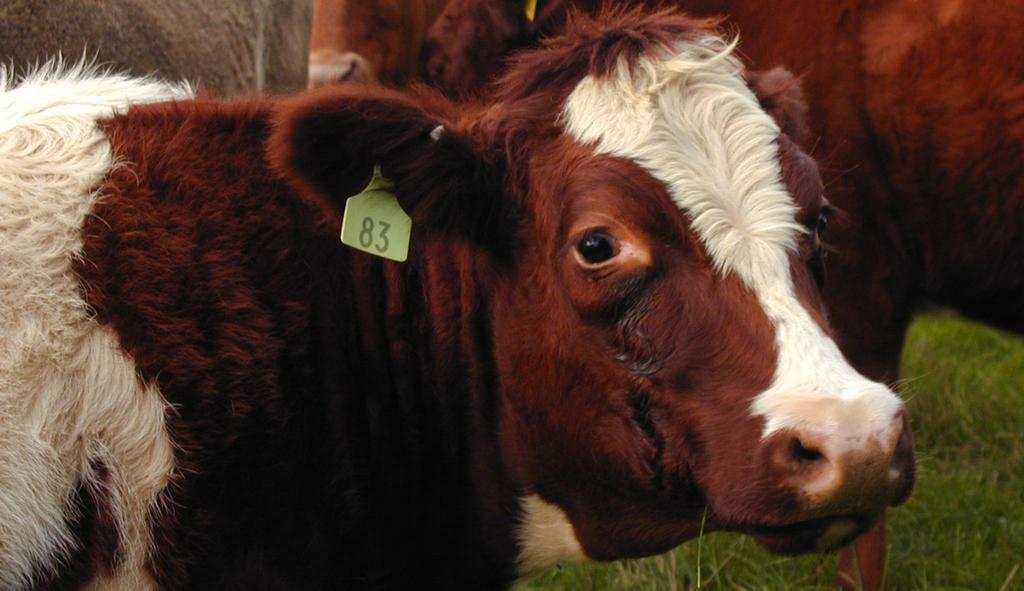In one or two sentences, can you explain what this image depicts? In this image we can see cattle standing on the ground. 